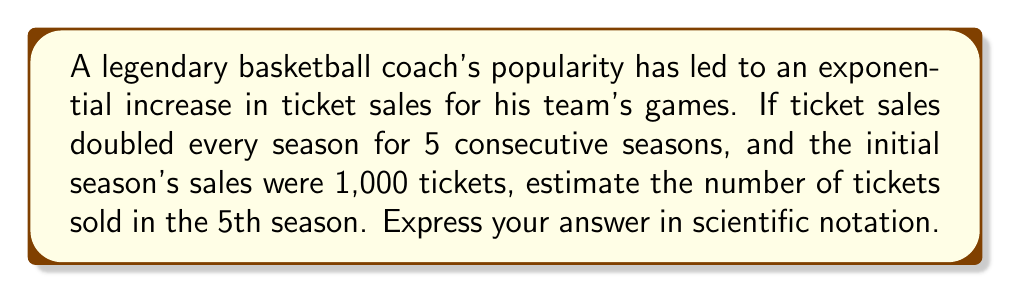Help me with this question. Let's approach this step-by-step:

1) The initial number of tickets sold: 1,000

2) The growth factor each season: 2 (doubles every season)

3) Number of seasons: 5

4) We can represent this exponential growth using the formula:
   $$ A = A_0 \cdot r^n $$
   Where:
   $A$ is the final amount
   $A_0$ is the initial amount
   $r$ is the growth factor
   $n$ is the number of time periods

5) Plugging in our values:
   $$ A = 1,000 \cdot 2^5 $$

6) Calculate $2^5$:
   $$ 2^5 = 2 \cdot 2 \cdot 2 \cdot 2 \cdot 2 = 32 $$

7) Multiply:
   $$ A = 1,000 \cdot 32 = 32,000 $$

8) Convert to scientific notation:
   $$ 32,000 = 3.2 \times 10^4 $$

Therefore, in the 5th season, approximately $3.2 \times 10^4$ tickets were sold.
Answer: $3.2 \times 10^4$ 